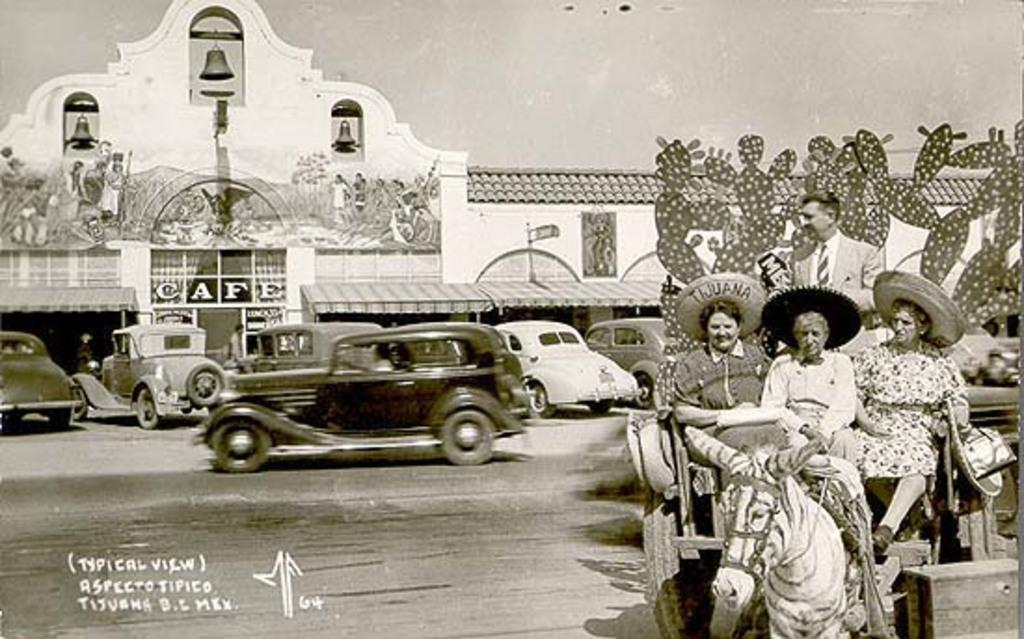Describe this image in one or two sentences. This is a black and white picture. On the right there are few persons riding in a horse cart on the road. In the background there are vehicles on the road,buildings,windows,glass,curtain,three bells hanged to a pole,drawings on the wall,On the right side we can see craft items and this is a sky. 